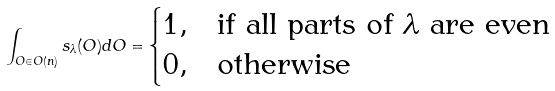<formula> <loc_0><loc_0><loc_500><loc_500>\int _ { O \in O ( n ) } s _ { \lambda } ( O ) d O = \begin{cases} 1 , & \text {if all parts of $\lambda$ are even } \\ 0 , & \text {otherwise} \end{cases}</formula> 